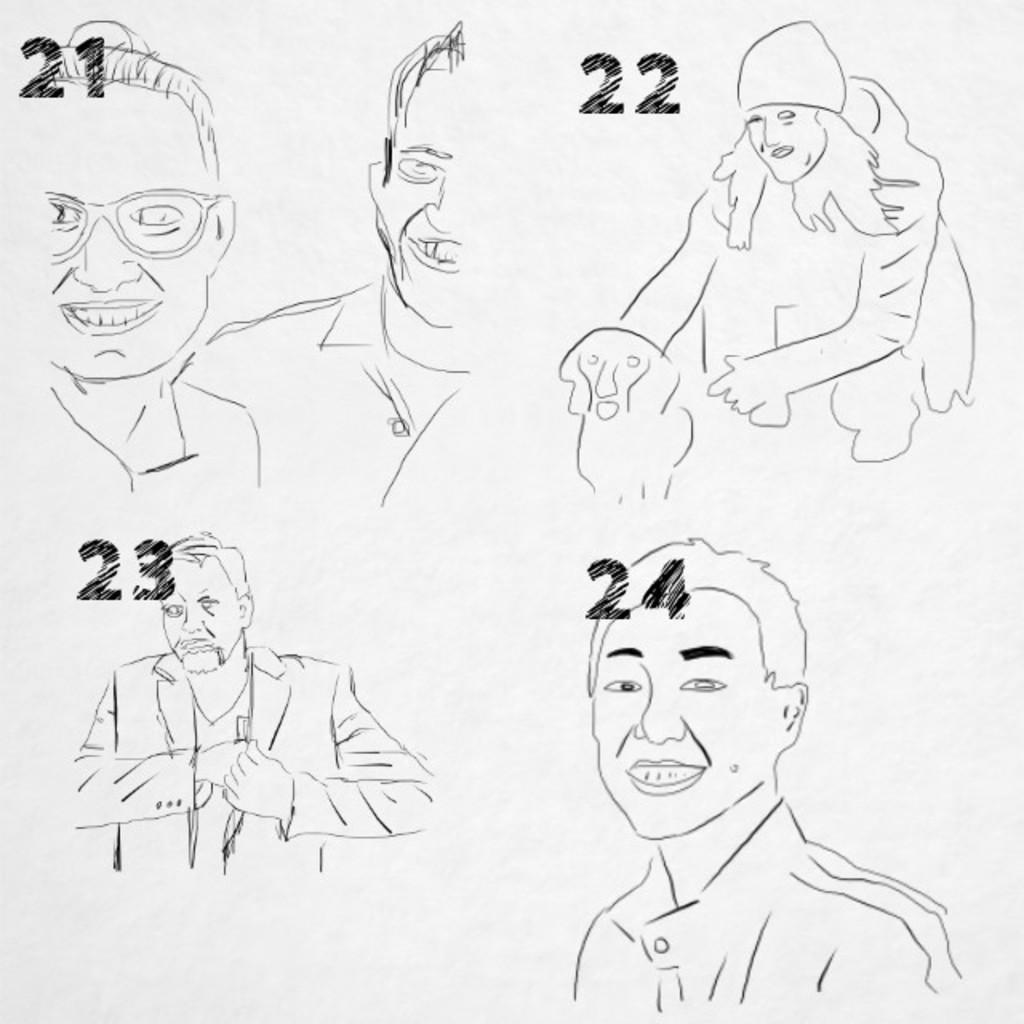What is the main subject of the image? The main subject of the image is a sketch. What can be seen in the sketch? The sketch contains a few persons and a dog. Can you tell me how many kitties are playing with the dog in the sketch? There are no kitties present in the sketch; it only includes a dog and a few persons. What disease is the dog in the sketch suffering from? There is no information about the dog's health in the sketch, so it cannot be determined from the image. 